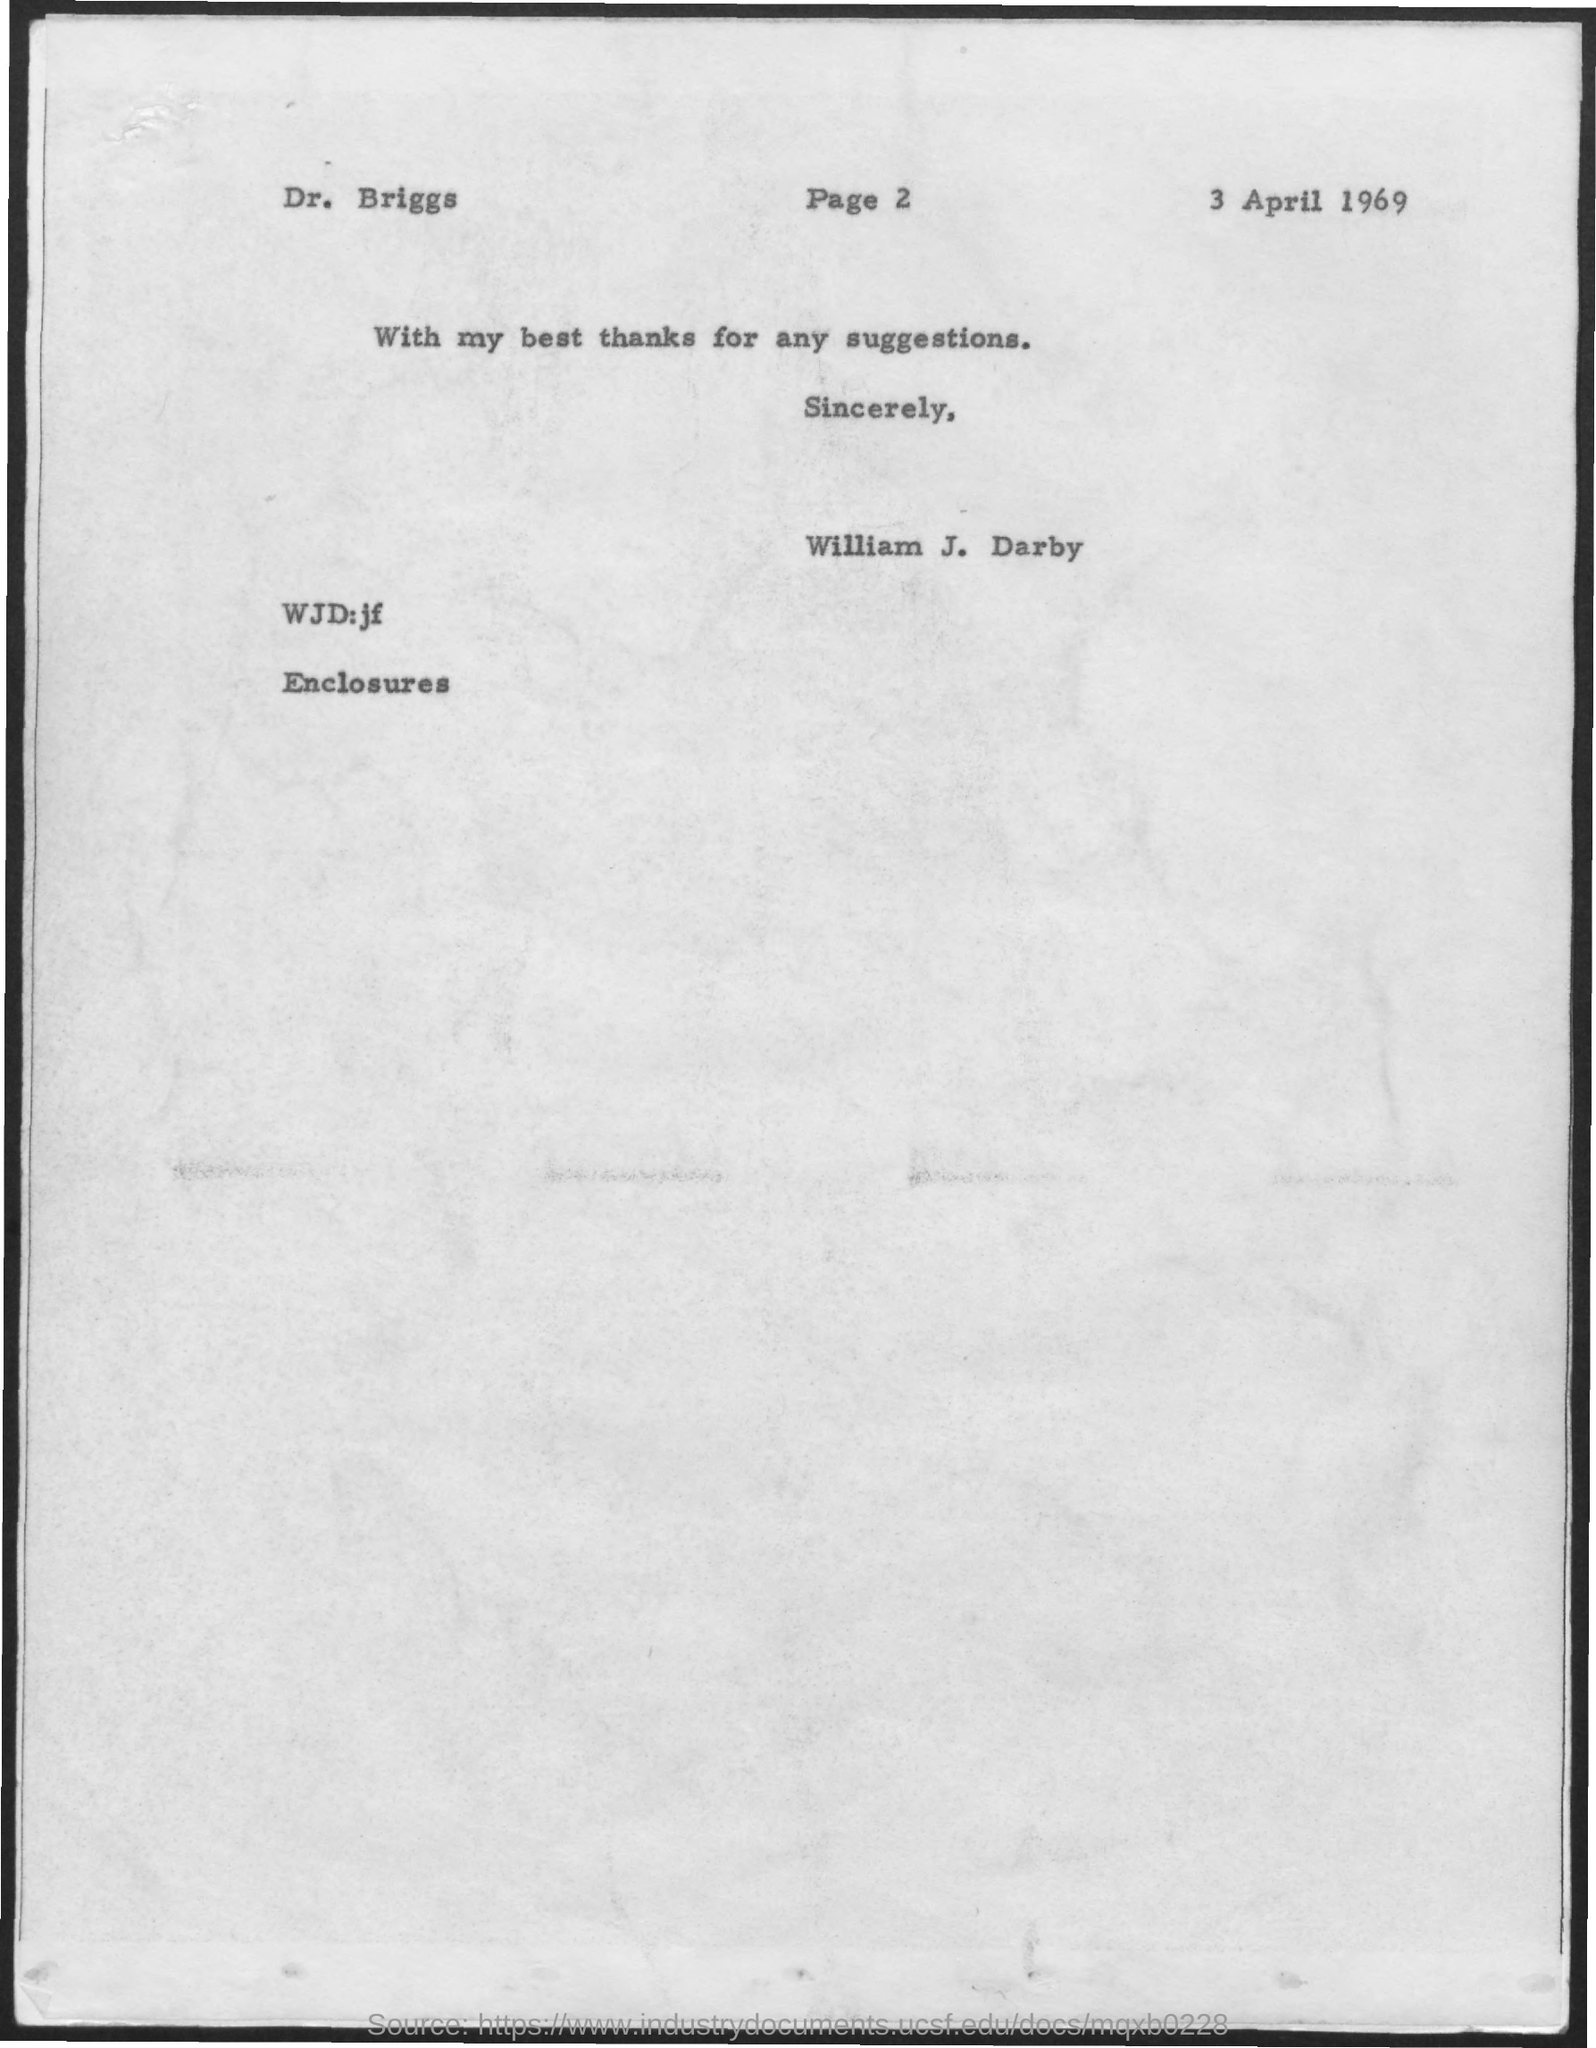Mention a couple of crucial points in this snapshot. The date mentioned is April 3rd, 1969. 